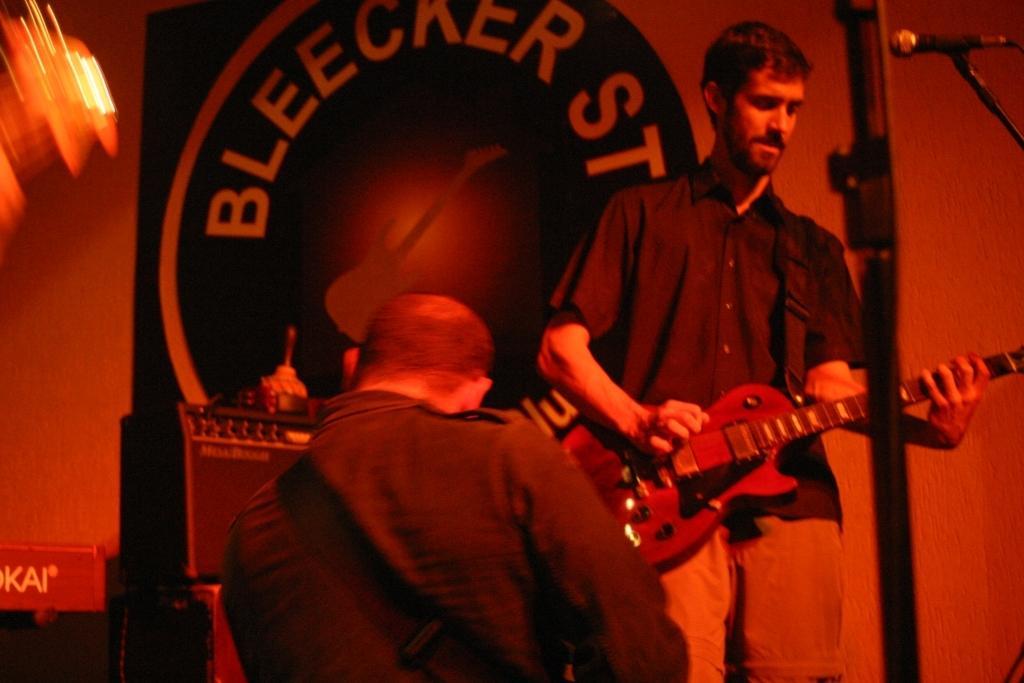Describe this image in one or two sentences. in the center we can see two persons holding guitar. On the right top we can see microphone. And coming to back we can see banner and wall. 